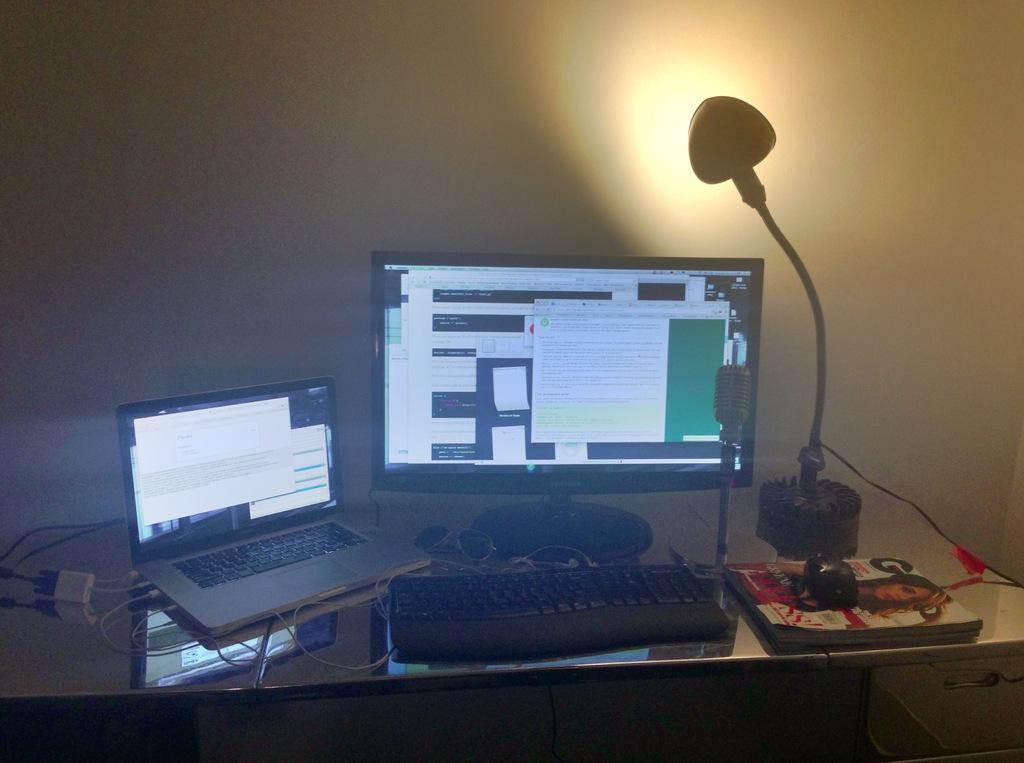<image>
Offer a succinct explanation of the picture presented. Computer next to a magazine that has the letter G on it. 